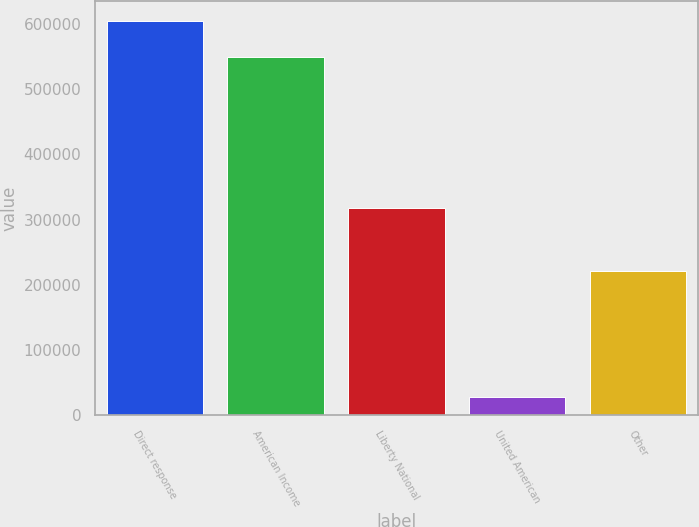Convert chart. <chart><loc_0><loc_0><loc_500><loc_500><bar_chart><fcel>Direct response<fcel>American Income<fcel>Liberty National<fcel>United American<fcel>Other<nl><fcel>604588<fcel>549540<fcel>317413<fcel>27740<fcel>221486<nl></chart> 